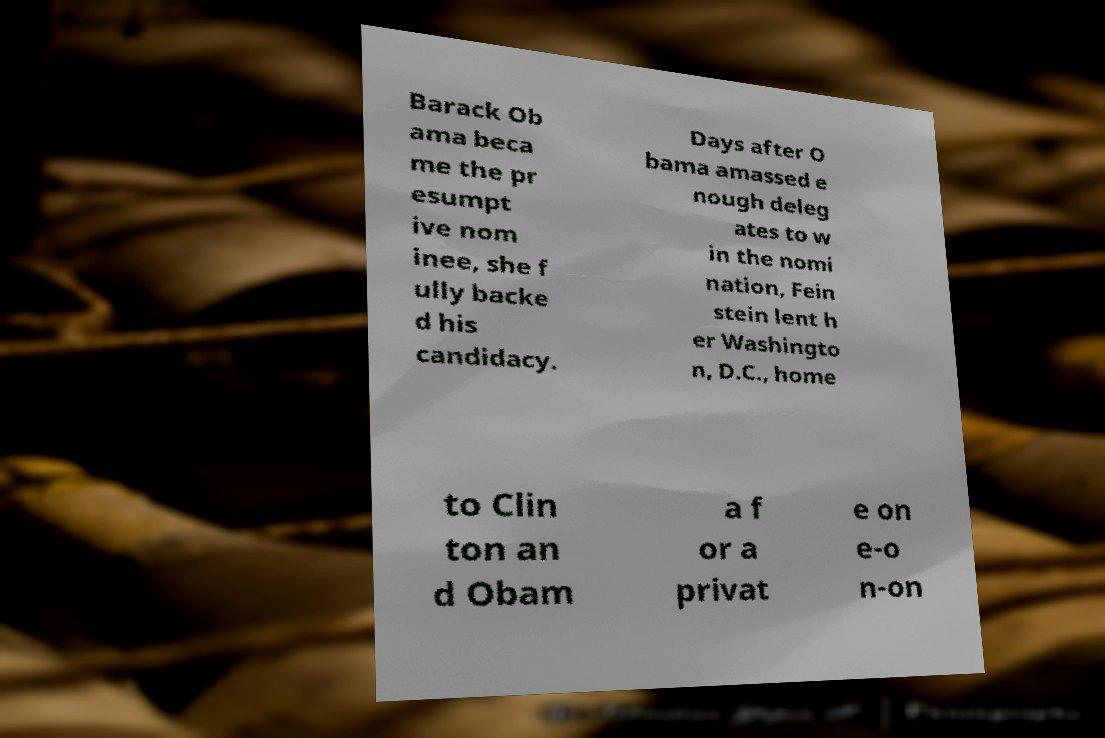Please read and relay the text visible in this image. What does it say? Barack Ob ama beca me the pr esumpt ive nom inee, she f ully backe d his candidacy. Days after O bama amassed e nough deleg ates to w in the nomi nation, Fein stein lent h er Washingto n, D.C., home to Clin ton an d Obam a f or a privat e on e-o n-on 